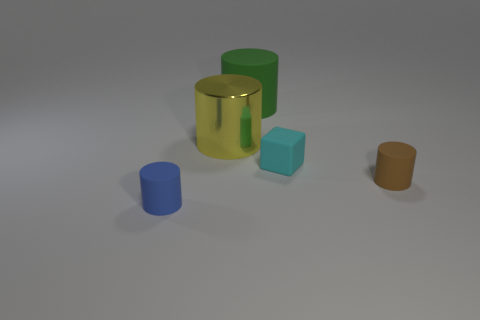What number of shiny things are either large yellow objects or small blue things?
Your answer should be compact. 1. What material is the small cylinder that is right of the tiny thing to the left of the tiny cyan object?
Ensure brevity in your answer.  Rubber. What number of objects are cyan metallic cylinders or cylinders right of the yellow metallic cylinder?
Give a very brief answer. 2. There is a green cylinder that is made of the same material as the blue thing; what is its size?
Ensure brevity in your answer.  Large. How many cyan objects are either small rubber cylinders or tiny objects?
Make the answer very short. 1. Is there anything else that is the same material as the big green cylinder?
Provide a short and direct response. Yes. Is the shape of the rubber thing that is behind the cyan rubber cube the same as the tiny object that is in front of the brown object?
Offer a terse response. Yes. How many blue shiny things are there?
Your answer should be very brief. 0. What shape is the large object that is the same material as the small cyan object?
Your response must be concise. Cylinder. Is there any other thing that has the same color as the matte cube?
Your answer should be compact. No. 